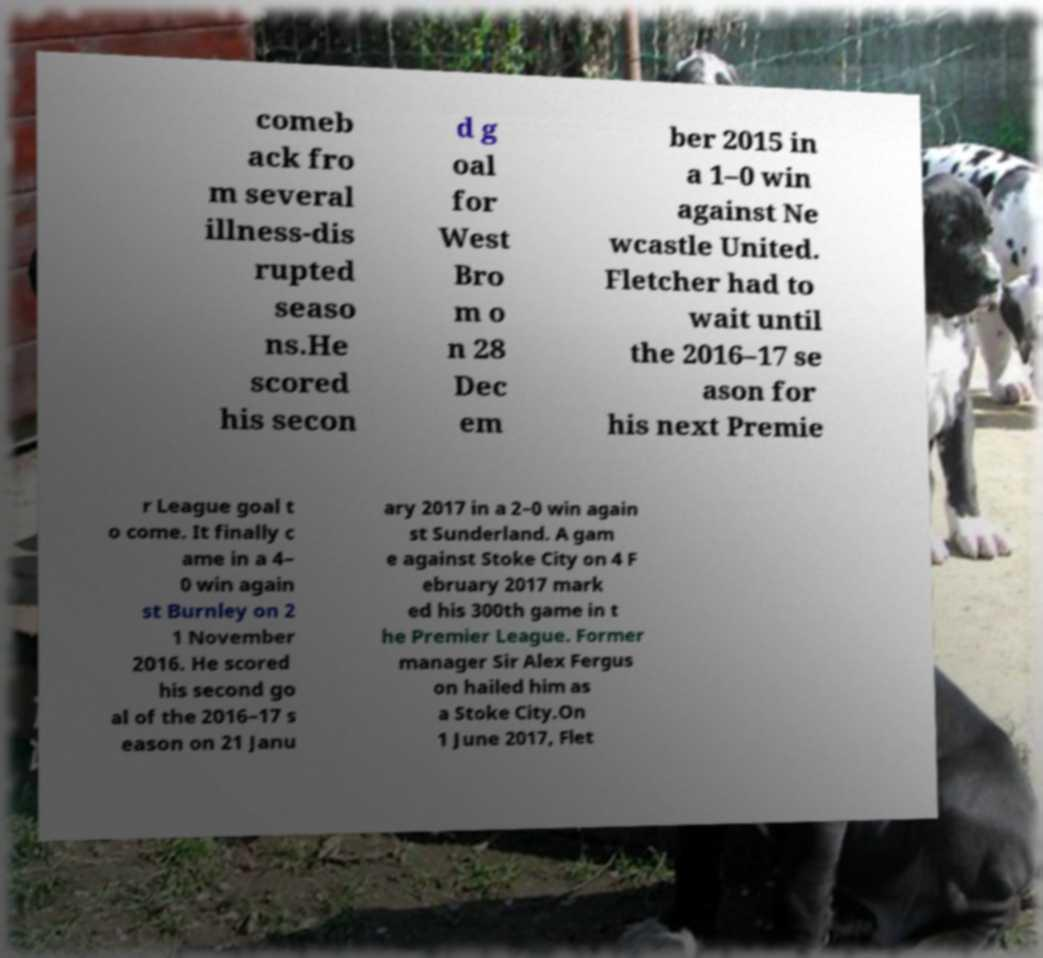What messages or text are displayed in this image? I need them in a readable, typed format. comeb ack fro m several illness-dis rupted seaso ns.He scored his secon d g oal for West Bro m o n 28 Dec em ber 2015 in a 1–0 win against Ne wcastle United. Fletcher had to wait until the 2016–17 se ason for his next Premie r League goal t o come. It finally c ame in a 4– 0 win again st Burnley on 2 1 November 2016. He scored his second go al of the 2016–17 s eason on 21 Janu ary 2017 in a 2–0 win again st Sunderland. A gam e against Stoke City on 4 F ebruary 2017 mark ed his 300th game in t he Premier League. Former manager Sir Alex Fergus on hailed him as a Stoke City.On 1 June 2017, Flet 